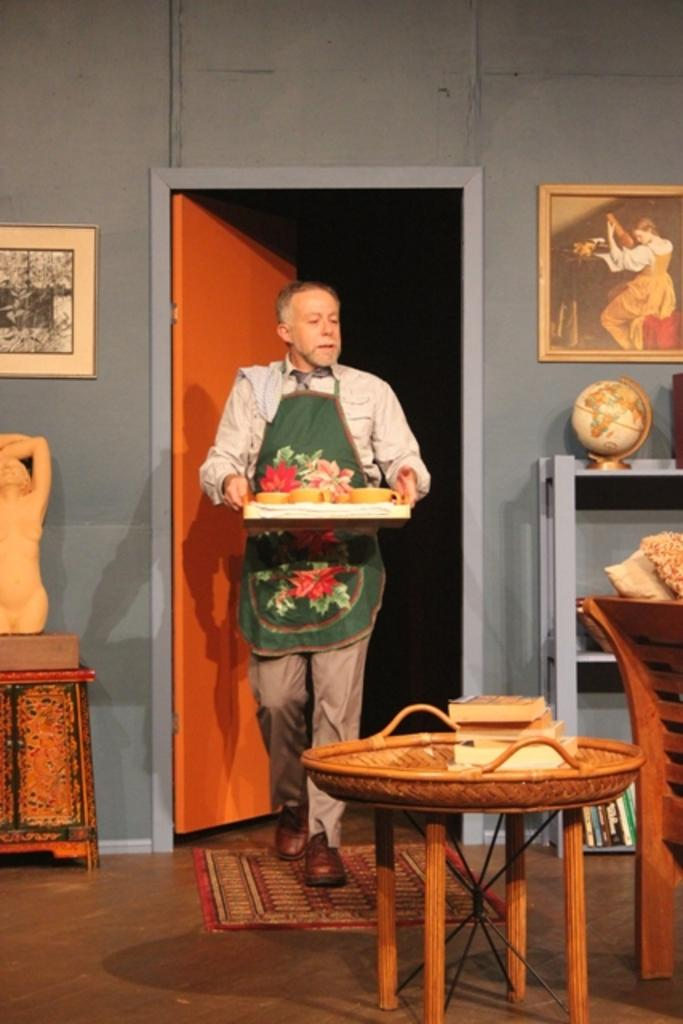What type of structure can be seen in the image? There is a wall in the image. What is hanging on the wall? There is a photo frame in the image. Is there any entrance or exit visible in the image? Yes, there is a door in the image. What is the man in the image holding? The man is holding a tray in the image. What type of object is related to geography in the image? There is a globe in the image. What type of furniture is present in the image? There is a chair in the image. What type of joke is being told by the river in the image? There is no river present in the image, and therefore no joke can be told by it. Who is the representative of the people in the image? There is no representative of the people in the image, as it does not depict a group of people or a situation that would require representation. 